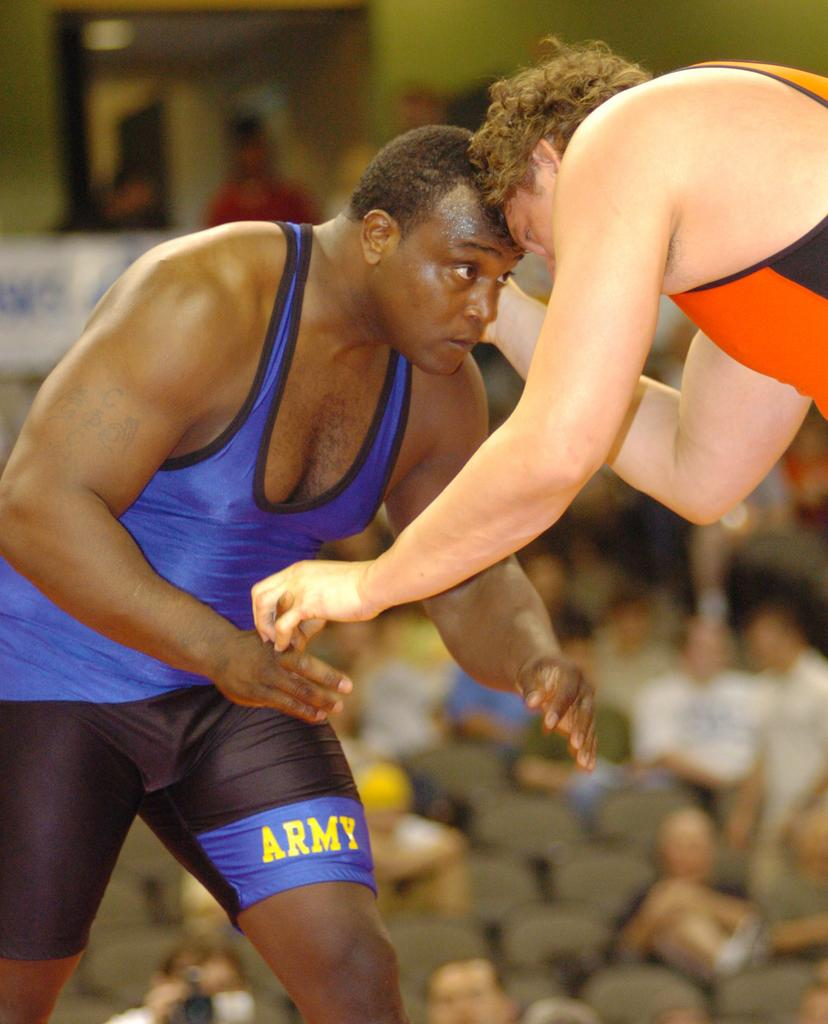<image>
Render a clear and concise summary of the photo. The wrester shown wears the word Army on his shorts. 